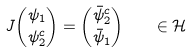<formula> <loc_0><loc_0><loc_500><loc_500>J \binom { \psi _ { 1 } } { \psi _ { 2 } ^ { c } } = \binom { \bar { \psi } _ { 2 } ^ { c } } { \bar { \psi } _ { 1 } } \quad \in \mathcal { H }</formula> 